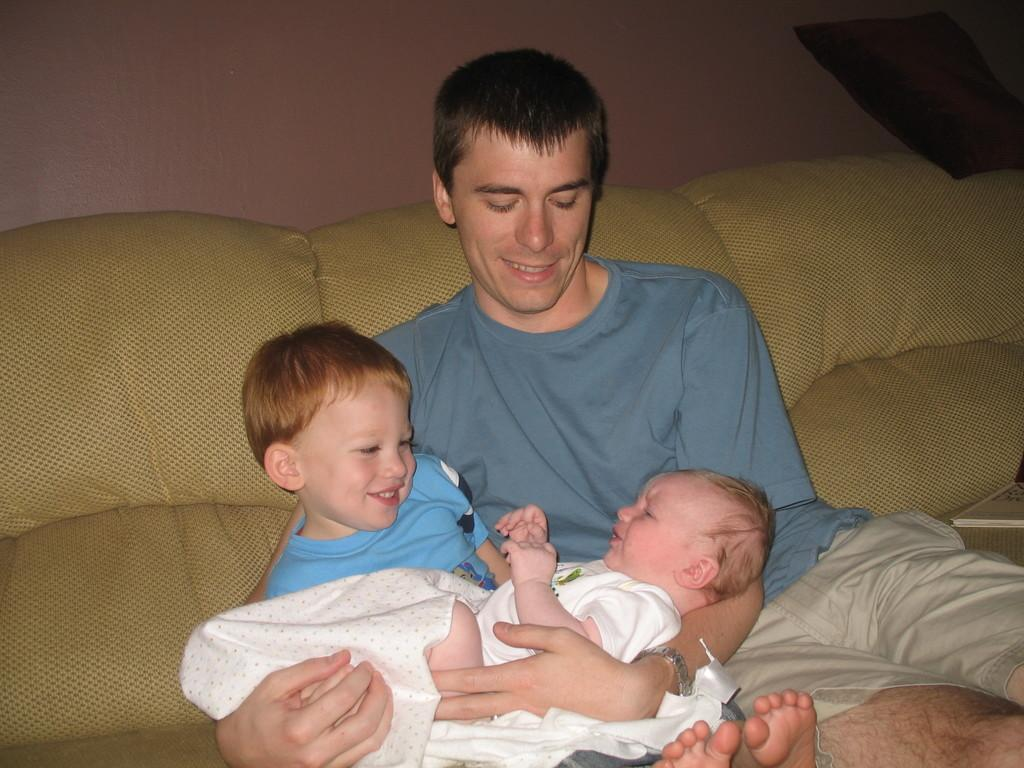Who is present in the image? There is a man, a kid, and an infant in the image. What are the man and the kid doing in the image? Both the man and the kid are sitting on a sofa. How is the infant positioned in the image? The infant is lying on the laps of the man and the kid. What type of metal is the sofa made of in the image? The image does not provide information about the material the sofa is made of, so it is not possible to determine if it is made of metal. 